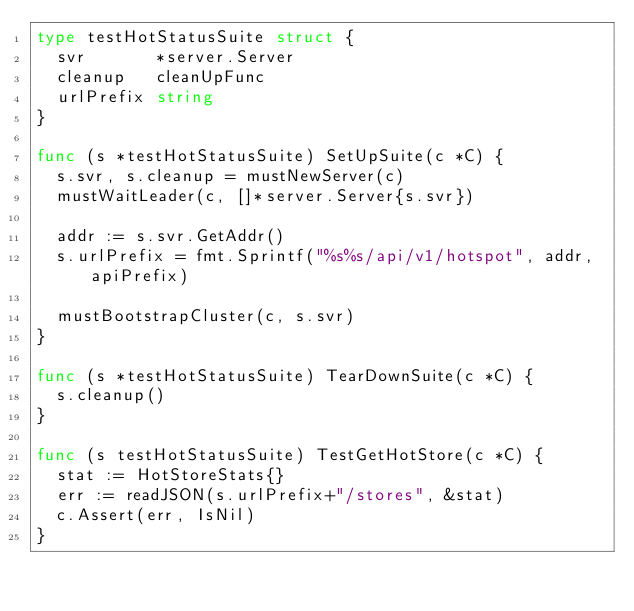Convert code to text. <code><loc_0><loc_0><loc_500><loc_500><_Go_>type testHotStatusSuite struct {
	svr       *server.Server
	cleanup   cleanUpFunc
	urlPrefix string
}

func (s *testHotStatusSuite) SetUpSuite(c *C) {
	s.svr, s.cleanup = mustNewServer(c)
	mustWaitLeader(c, []*server.Server{s.svr})

	addr := s.svr.GetAddr()
	s.urlPrefix = fmt.Sprintf("%s%s/api/v1/hotspot", addr, apiPrefix)

	mustBootstrapCluster(c, s.svr)
}

func (s *testHotStatusSuite) TearDownSuite(c *C) {
	s.cleanup()
}

func (s testHotStatusSuite) TestGetHotStore(c *C) {
	stat := HotStoreStats{}
	err := readJSON(s.urlPrefix+"/stores", &stat)
	c.Assert(err, IsNil)
}
</code> 